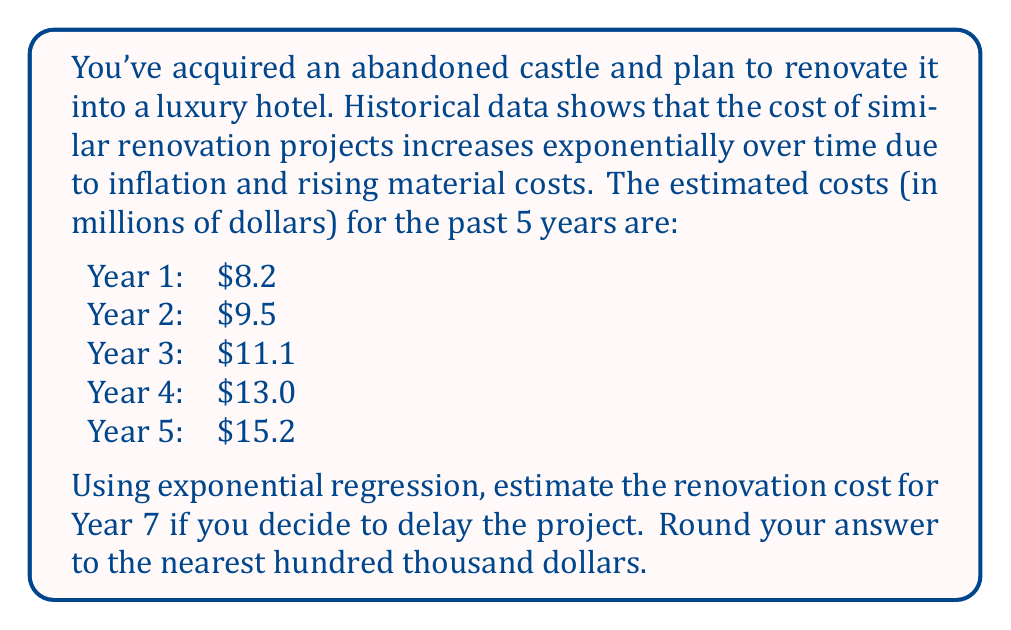What is the answer to this math problem? To solve this problem using exponential regression, we'll follow these steps:

1) The exponential model has the form $y = ae^{bx}$, where $y$ is the cost, $x$ is the year, and $a$ and $b$ are constants we need to determine.

2) We'll use the logarithmic form of this equation: $\ln(y) = \ln(a) + bx$

3) Let $Y = \ln(y)$ and $A = \ln(a)$. Now we have a linear equation: $Y = A + bx$

4) We'll use the following formulas:
   $b = \frac{n\sum(xY) - \sum x \sum Y}{n\sum x^2 - (\sum x)^2}$
   $A = \frac{\sum Y}{n} - b\frac{\sum x}{n}$

5) Let's calculate the necessary sums:
   $\sum x = 1 + 2 + 3 + 4 + 5 = 15$
   $\sum x^2 = 1 + 4 + 9 + 16 + 25 = 55$
   $\sum Y = \ln(8.2) + \ln(9.5) + \ln(11.1) + \ln(13.0) + \ln(15.2) = 12.8901$
   $\sum(xY) = 1\ln(8.2) + 2\ln(9.5) + 3\ln(11.1) + 4\ln(13.0) + 5\ln(15.2) = 43.5222$

6) Now we can calculate $b$:
   $b = \frac{5(43.5222) - 15(12.8901)}{5(55) - 15^2} = 0.1573$

7) And $A$:
   $A = \frac{12.8901}{5} - 0.1573\frac{15}{5} = 2.0723$

8) So $a = e^A = e^{2.0723} = 7.9424$

9) Our exponential model is: $y = 7.9424e^{0.1573x}$

10) For Year 7, $x = 7$. Let's calculate:
    $y = 7.9424e^{0.1573(7)} = 20.7859$

11) Rounding to the nearest hundred thousand: $20.8$ million dollars.
Answer: $20.8 million 